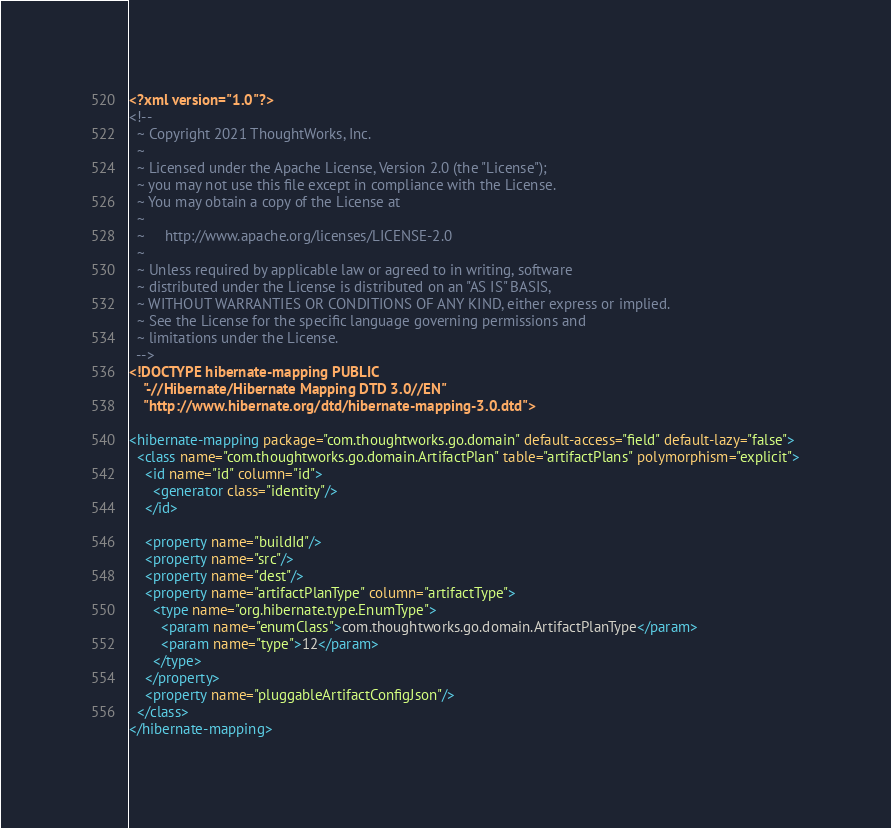<code> <loc_0><loc_0><loc_500><loc_500><_XML_><?xml version="1.0"?>
<!--
  ~ Copyright 2021 ThoughtWorks, Inc.
  ~
  ~ Licensed under the Apache License, Version 2.0 (the "License");
  ~ you may not use this file except in compliance with the License.
  ~ You may obtain a copy of the License at
  ~
  ~     http://www.apache.org/licenses/LICENSE-2.0
  ~
  ~ Unless required by applicable law or agreed to in writing, software
  ~ distributed under the License is distributed on an "AS IS" BASIS,
  ~ WITHOUT WARRANTIES OR CONDITIONS OF ANY KIND, either express or implied.
  ~ See the License for the specific language governing permissions and
  ~ limitations under the License.
  -->
<!DOCTYPE hibernate-mapping PUBLIC
    "-//Hibernate/Hibernate Mapping DTD 3.0//EN"
    "http://www.hibernate.org/dtd/hibernate-mapping-3.0.dtd">

<hibernate-mapping package="com.thoughtworks.go.domain" default-access="field" default-lazy="false">
  <class name="com.thoughtworks.go.domain.ArtifactPlan" table="artifactPlans" polymorphism="explicit">
    <id name="id" column="id">
      <generator class="identity"/>
    </id>

    <property name="buildId"/>
    <property name="src"/>
    <property name="dest"/>
    <property name="artifactPlanType" column="artifactType">
      <type name="org.hibernate.type.EnumType">
        <param name="enumClass">com.thoughtworks.go.domain.ArtifactPlanType</param>
        <param name="type">12</param>
      </type>
    </property>
    <property name="pluggableArtifactConfigJson"/>
  </class>
</hibernate-mapping>

</code> 